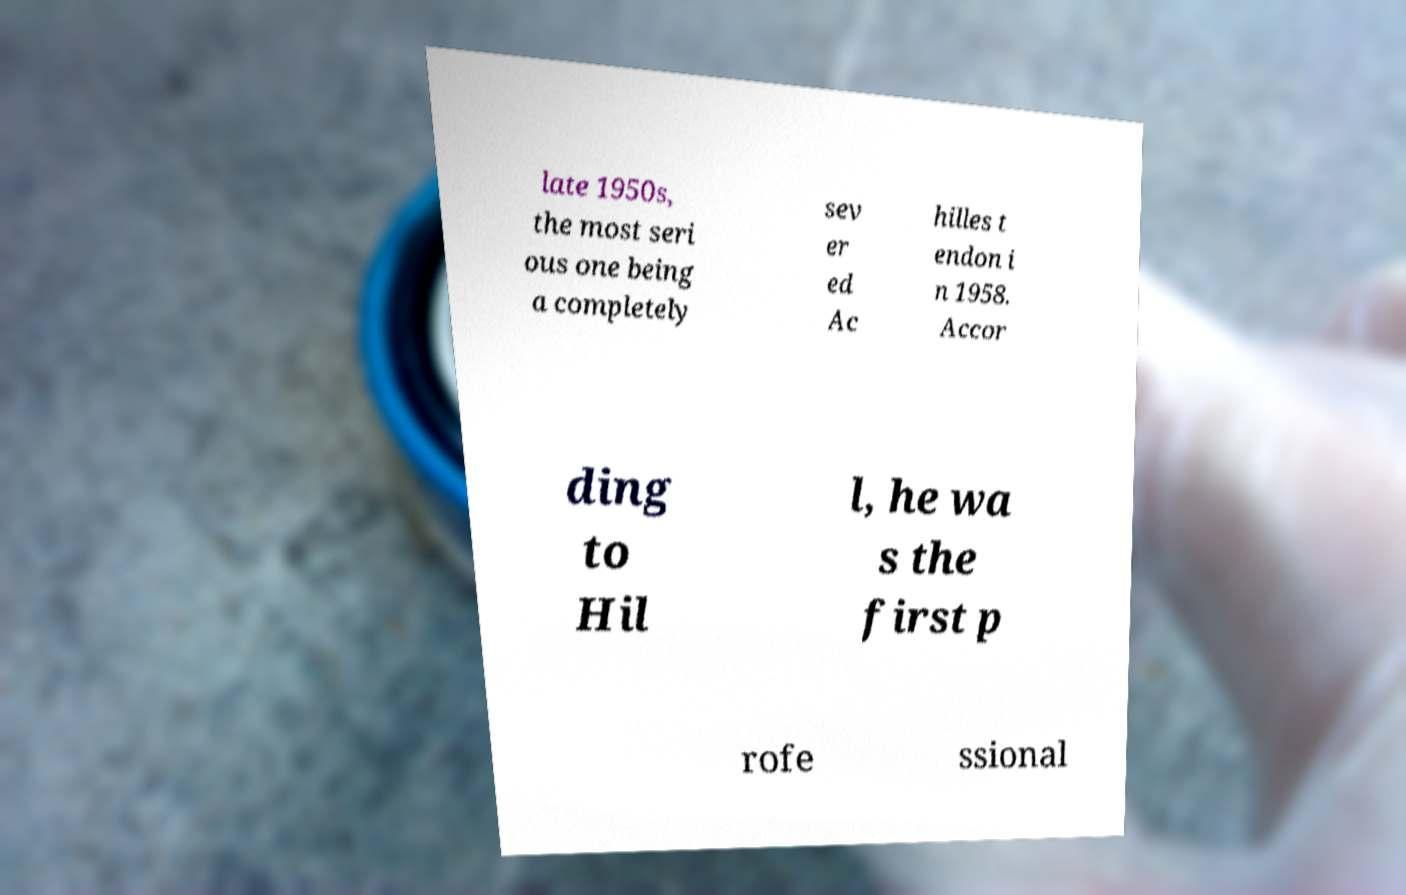For documentation purposes, I need the text within this image transcribed. Could you provide that? late 1950s, the most seri ous one being a completely sev er ed Ac hilles t endon i n 1958. Accor ding to Hil l, he wa s the first p rofe ssional 